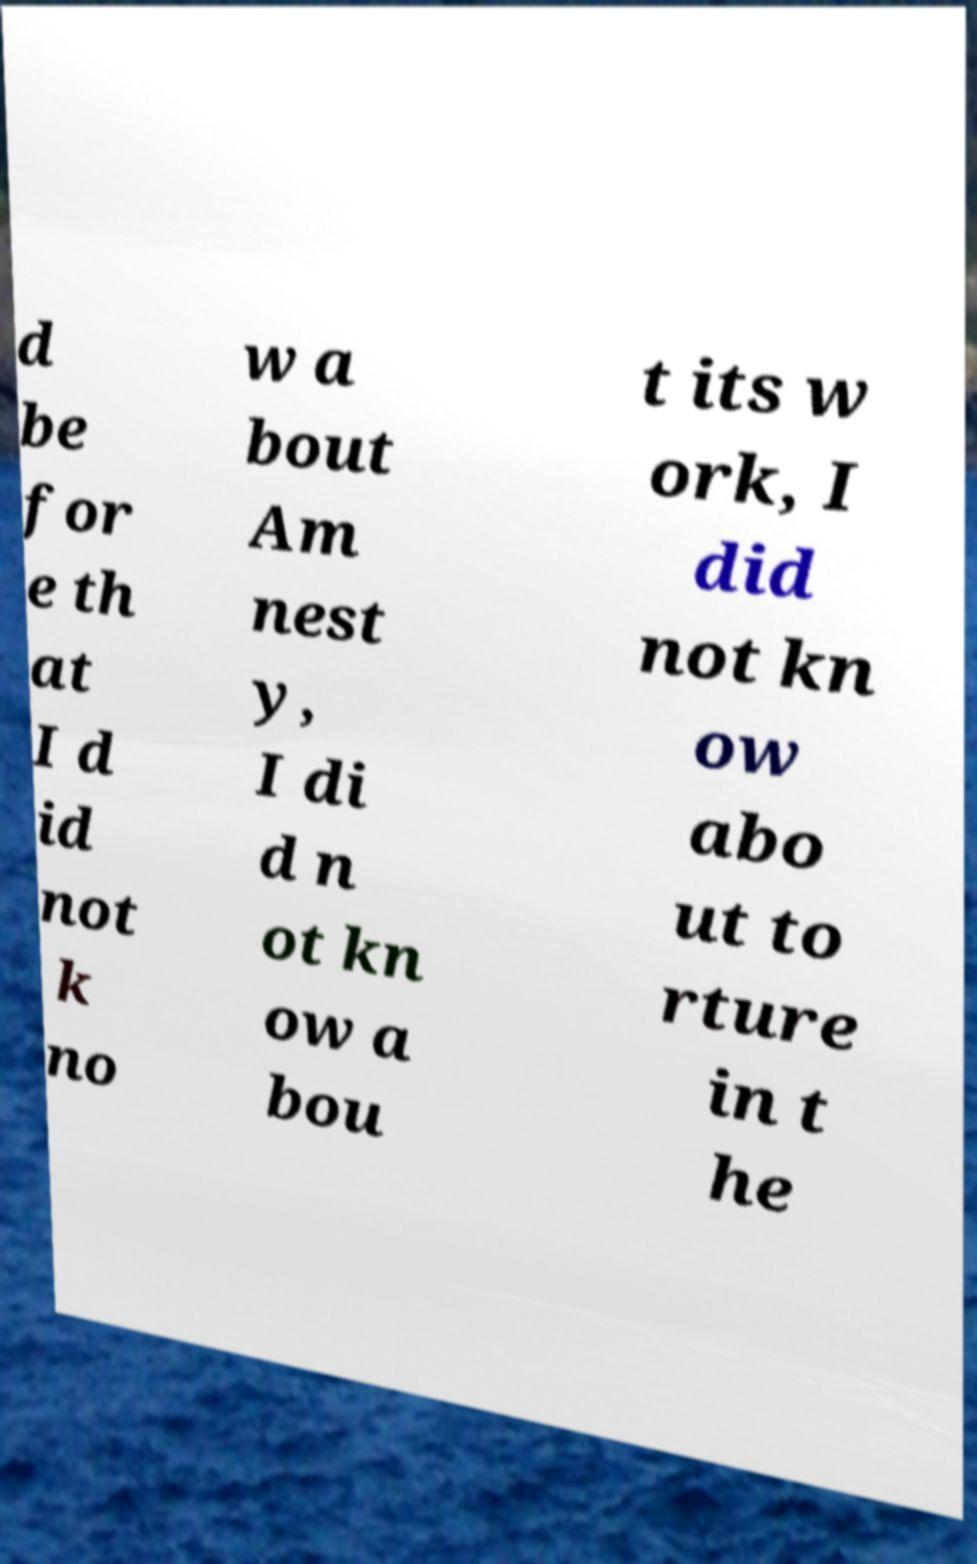Could you extract and type out the text from this image? d be for e th at I d id not k no w a bout Am nest y, I di d n ot kn ow a bou t its w ork, I did not kn ow abo ut to rture in t he 